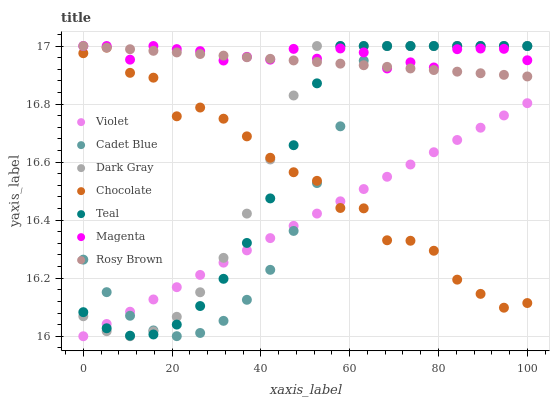Does Violet have the minimum area under the curve?
Answer yes or no. Yes. Does Magenta have the maximum area under the curve?
Answer yes or no. Yes. Does Rosy Brown have the minimum area under the curve?
Answer yes or no. No. Does Rosy Brown have the maximum area under the curve?
Answer yes or no. No. Is Rosy Brown the smoothest?
Answer yes or no. Yes. Is Chocolate the roughest?
Answer yes or no. Yes. Is Chocolate the smoothest?
Answer yes or no. No. Is Rosy Brown the roughest?
Answer yes or no. No. Does Violet have the lowest value?
Answer yes or no. Yes. Does Rosy Brown have the lowest value?
Answer yes or no. No. Does Magenta have the highest value?
Answer yes or no. Yes. Does Chocolate have the highest value?
Answer yes or no. No. Is Violet less than Rosy Brown?
Answer yes or no. Yes. Is Magenta greater than Violet?
Answer yes or no. Yes. Does Dark Gray intersect Rosy Brown?
Answer yes or no. Yes. Is Dark Gray less than Rosy Brown?
Answer yes or no. No. Is Dark Gray greater than Rosy Brown?
Answer yes or no. No. Does Violet intersect Rosy Brown?
Answer yes or no. No. 